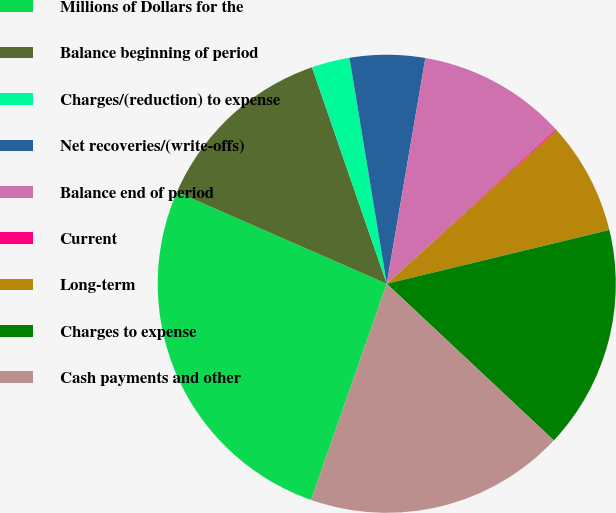Convert chart to OTSL. <chart><loc_0><loc_0><loc_500><loc_500><pie_chart><fcel>Millions of Dollars for the<fcel>Balance beginning of period<fcel>Charges/(reduction) to expense<fcel>Net recoveries/(write-offs)<fcel>Balance end of period<fcel>Current<fcel>Long-term<fcel>Charges to expense<fcel>Cash payments and other<nl><fcel>26.21%<fcel>13.14%<fcel>2.69%<fcel>5.3%<fcel>10.53%<fcel>0.08%<fcel>7.92%<fcel>15.76%<fcel>18.37%<nl></chart> 